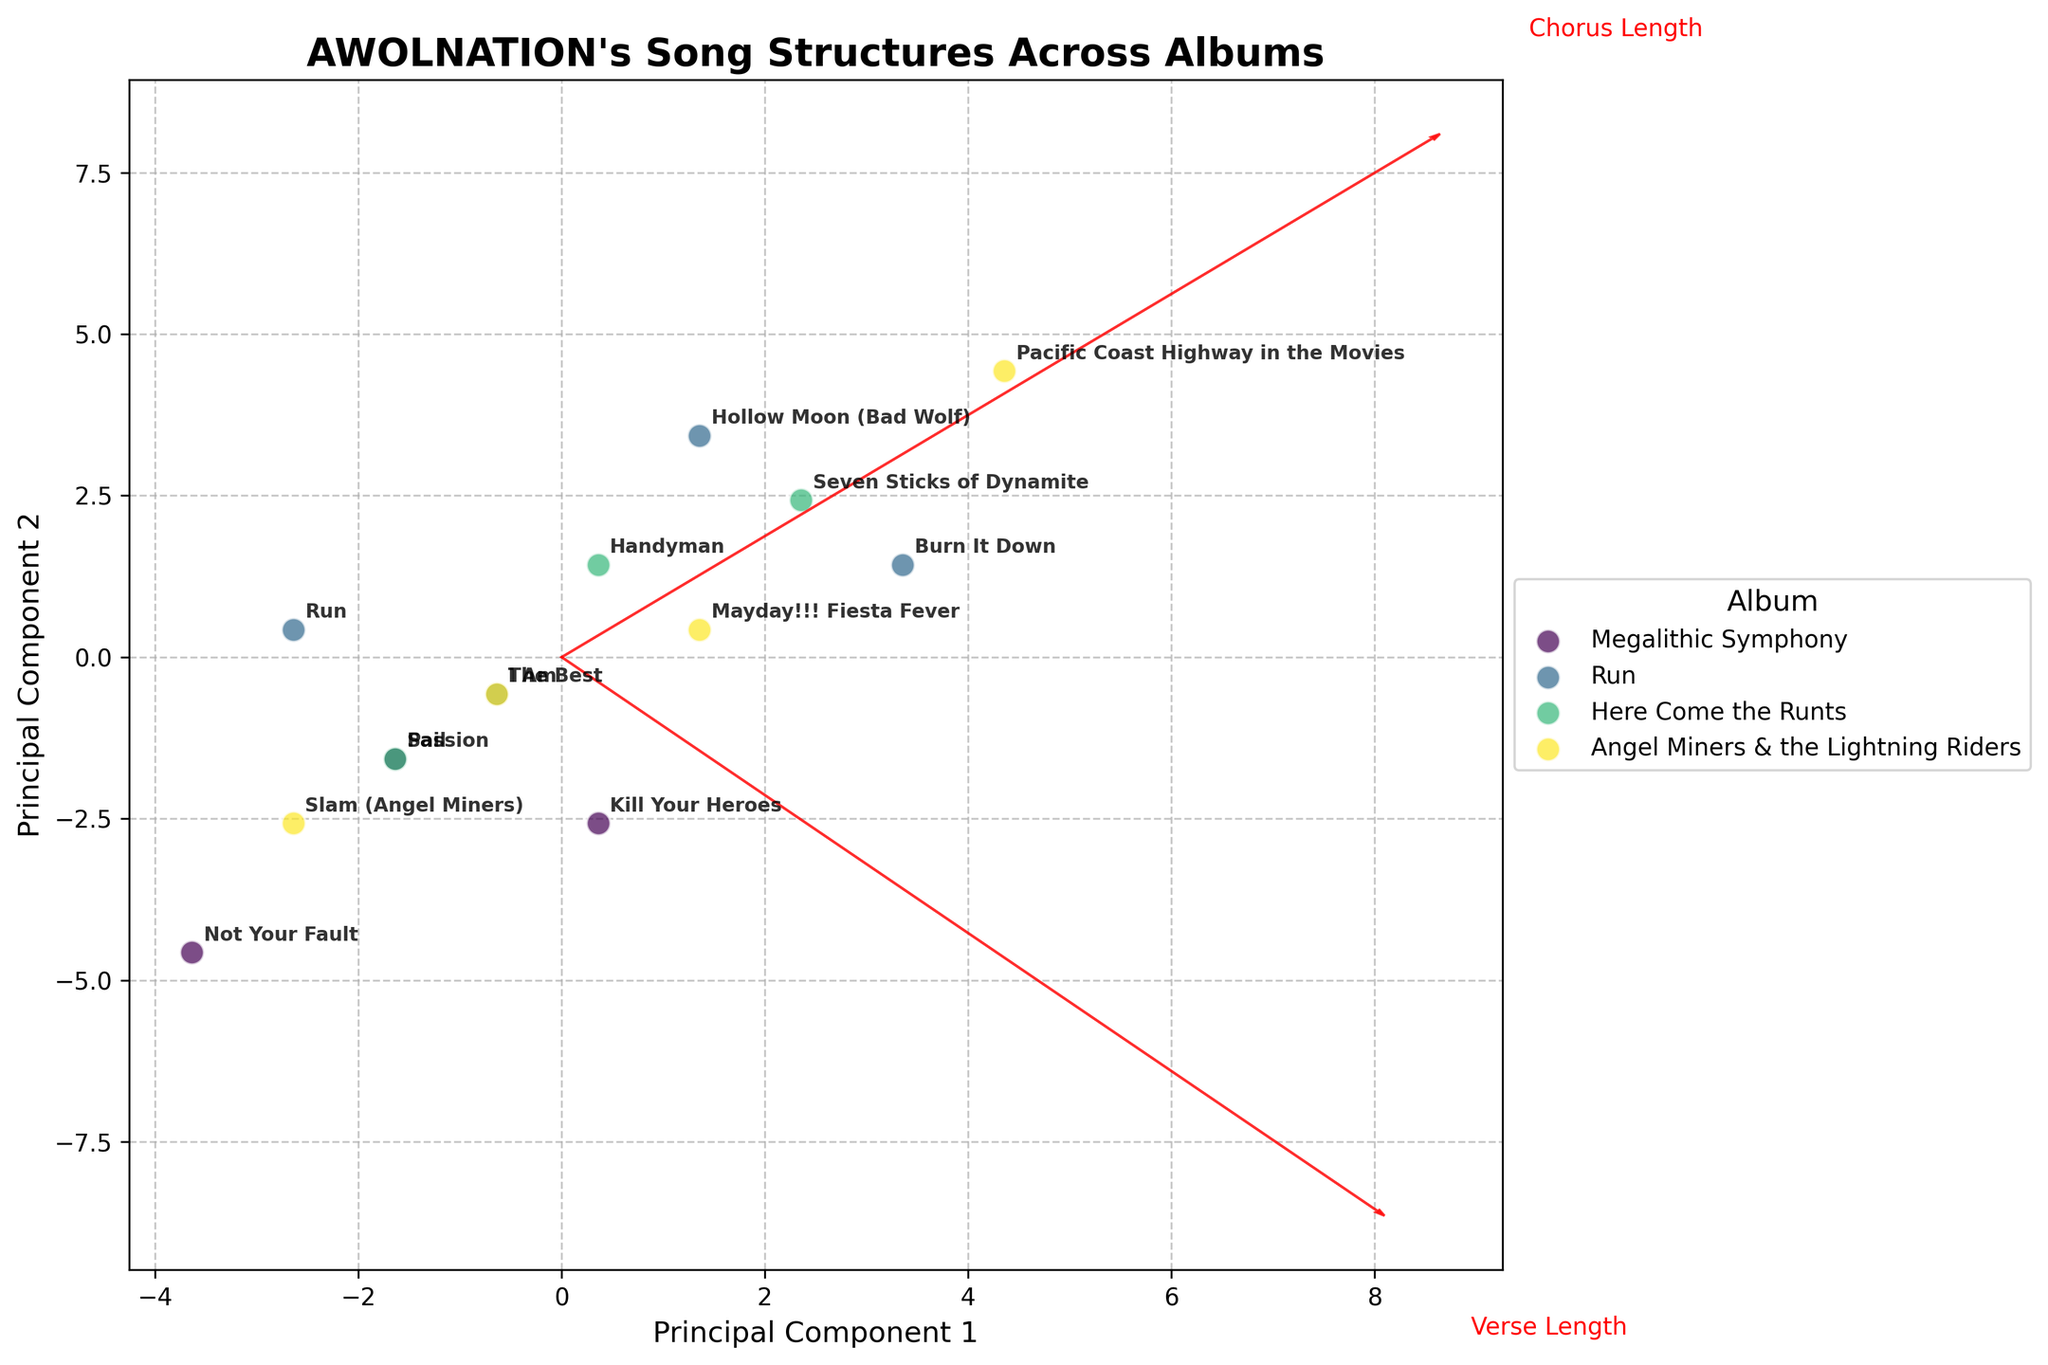What is the title of the plot? The title is usually displayed at the top of the plot. It summarizes the main subject of the visual.
Answer: "AWOLNATION's Song Structures Across Albums" Which album has the song with the longest combined verse and chorus length? First, identify the songs with the longest verse and chorus lengths. From the data, "Pacific Coast Highway in the Movies" from "Angel Miners & the Lightning Riders" has the combined length of 26 (Verse) + 21 (Chorus) = 47.
Answer: "Angel Miners & the Lightning Riders" Which album appears to have the most widely spread data points? Look at the distribution of the data points for each album on the biplot. "Run" shows a wider scattering of points compared to others.
Answer: "Run" How many distinct albums are compared in the plot? The plot legend or the data used to generate the plot indicate the number of distinct albums, which are usually color-coded separately. There are 4 albums listed in the provided data.
Answer: 4 Which feature vector (Verse Length or Chorus Length) has a larger influence on Principal Component 1? Look at the arrows that represent the feature vectors. The arrow corresponding to "Verse Length" is longer in the direction of Principal Component 1, suggesting it has a larger influence.
Answer: Verse Length Which song from "Megalithic Symphony" has the shortest chorus length? Refer to the data points related to "Megalithic Symphony" in the scatter plot. "Not Your Fault" has the shortest chorus length at 12.
Answer: "Not Your Fault" Compare the verse length of "Slam (Angel Miners)" and "Handyman." Which song has the longer verse? Identify the data points for "Slam (Angel Miners)" and "Handyman" on the plot. "Handyman" has a verse length of 22, which is longer than "Slam (Angel Miners)" with a verse length of 19.
Answer: "Handyman" What general trend, if any, can be observed between verse length and chorus length across all songs? Observe the overall distribution of points relative to the feature vectors. Generally, as verse length increases, chorus length also increases, indicating a positive correlation.
Answer: Positive correlation In which album is the song "Burn It Down" categorized? Locate "Burn It Down" on the plot and refer to the associated color or legend. According to the data provided, it is from the album "Run".
Answer: "Run" How do Verse Lengths in "Here Come the Runts" compare to those in "Angel Miners & the Lightning Riders"? Compare the spread of verse lengths for each album. "Angel Miners & the Lightning Riders" have a slightly higher range of verse lengths.
Answer: "Angel Miners & the Lightning Riders" 